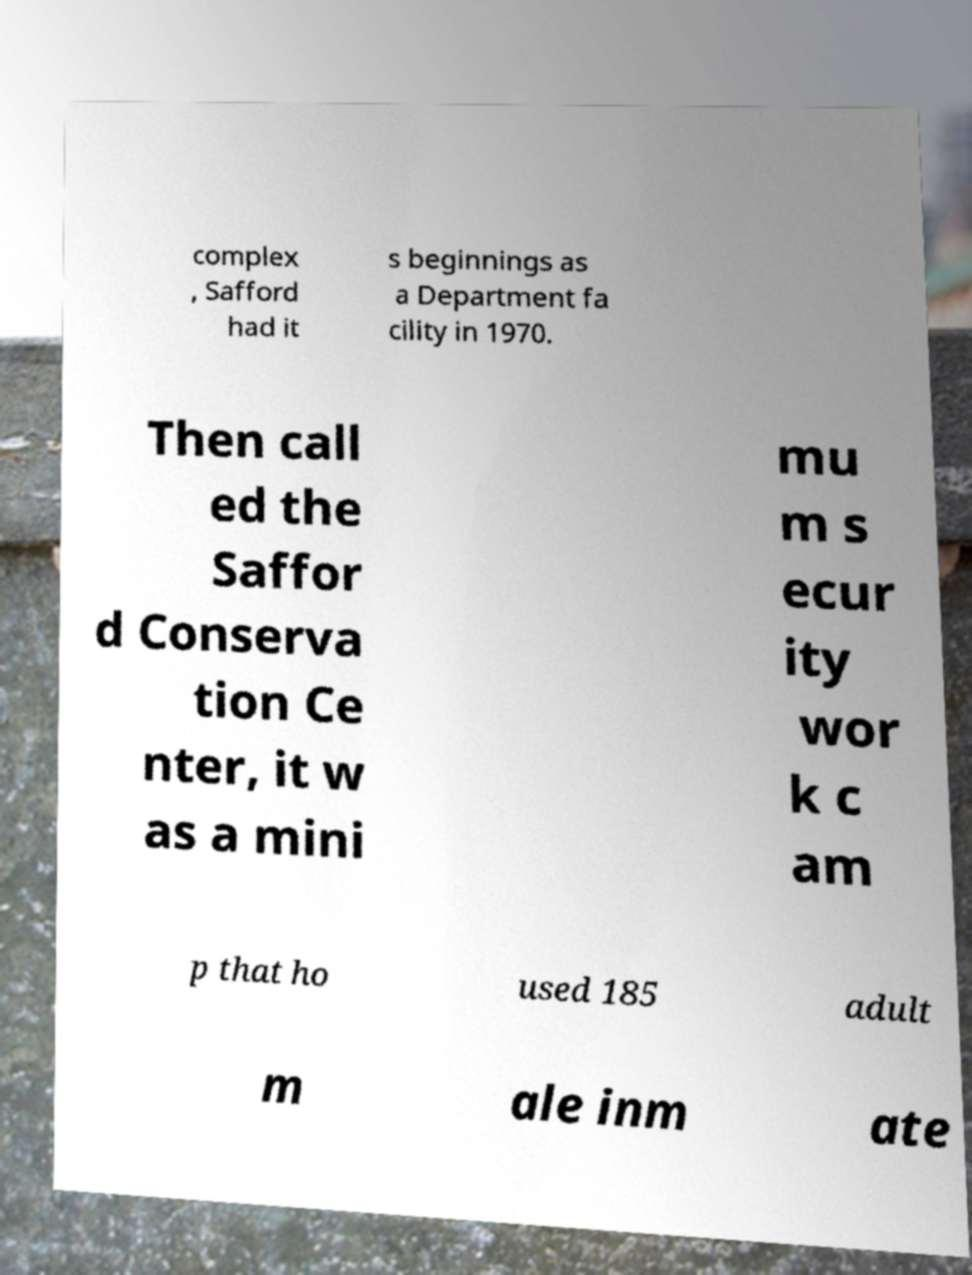For documentation purposes, I need the text within this image transcribed. Could you provide that? complex , Safford had it s beginnings as a Department fa cility in 1970. Then call ed the Saffor d Conserva tion Ce nter, it w as a mini mu m s ecur ity wor k c am p that ho used 185 adult m ale inm ate 